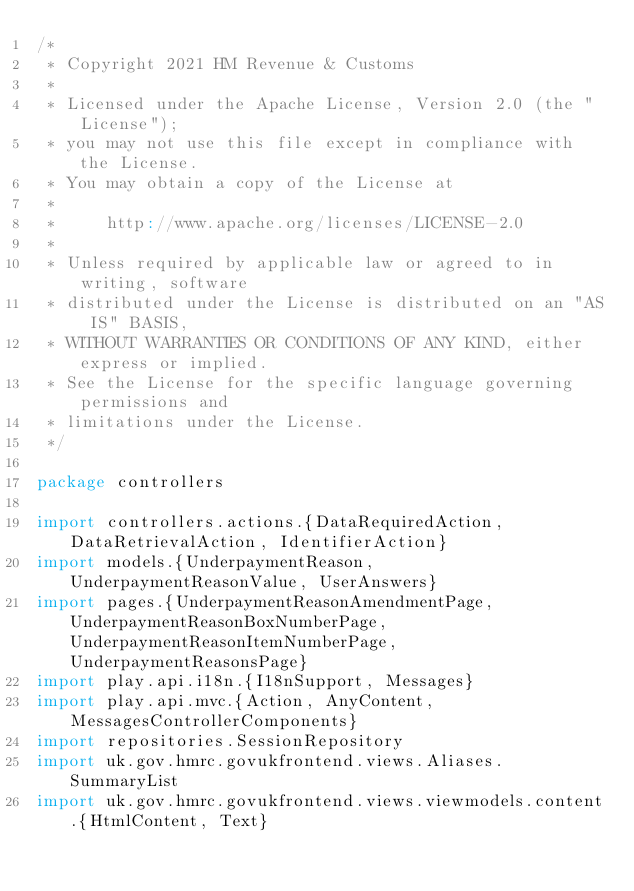<code> <loc_0><loc_0><loc_500><loc_500><_Scala_>/*
 * Copyright 2021 HM Revenue & Customs
 *
 * Licensed under the Apache License, Version 2.0 (the "License");
 * you may not use this file except in compliance with the License.
 * You may obtain a copy of the License at
 *
 *     http://www.apache.org/licenses/LICENSE-2.0
 *
 * Unless required by applicable law or agreed to in writing, software
 * distributed under the License is distributed on an "AS IS" BASIS,
 * WITHOUT WARRANTIES OR CONDITIONS OF ANY KIND, either express or implied.
 * See the License for the specific language governing permissions and
 * limitations under the License.
 */

package controllers

import controllers.actions.{DataRequiredAction, DataRetrievalAction, IdentifierAction}
import models.{UnderpaymentReason, UnderpaymentReasonValue, UserAnswers}
import pages.{UnderpaymentReasonAmendmentPage, UnderpaymentReasonBoxNumberPage, UnderpaymentReasonItemNumberPage, UnderpaymentReasonsPage}
import play.api.i18n.{I18nSupport, Messages}
import play.api.mvc.{Action, AnyContent, MessagesControllerComponents}
import repositories.SessionRepository
import uk.gov.hmrc.govukfrontend.views.Aliases.SummaryList
import uk.gov.hmrc.govukfrontend.views.viewmodels.content.{HtmlContent, Text}</code> 